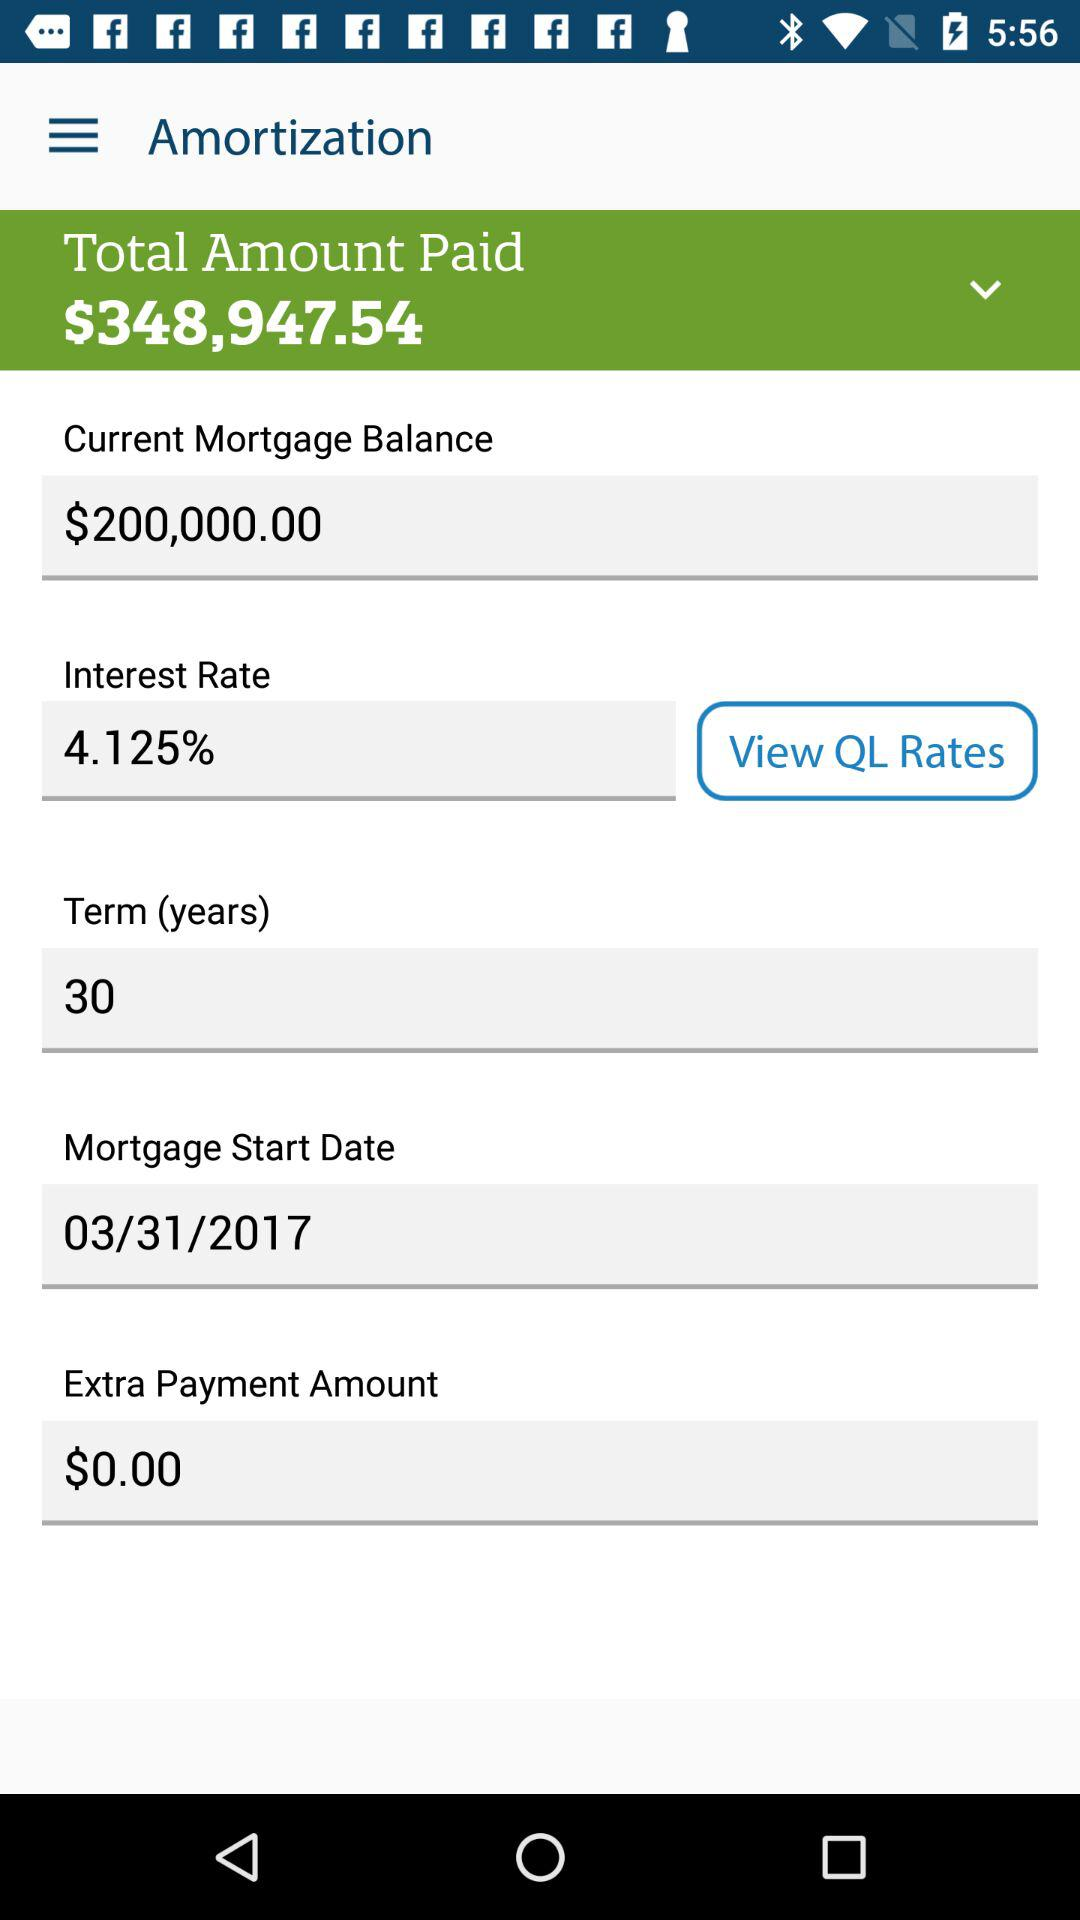How many years is the mortgage term?
Answer the question using a single word or phrase. 30 